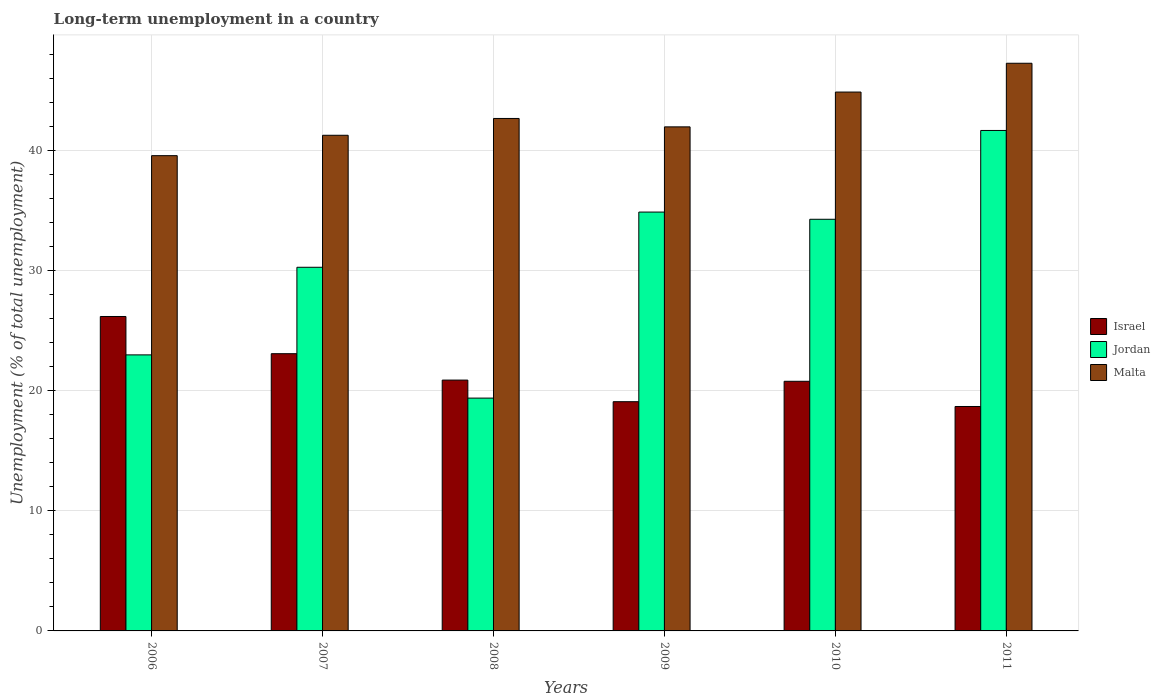How many different coloured bars are there?
Make the answer very short. 3. How many groups of bars are there?
Offer a very short reply. 6. Are the number of bars on each tick of the X-axis equal?
Ensure brevity in your answer.  Yes. How many bars are there on the 3rd tick from the right?
Offer a terse response. 3. What is the percentage of long-term unemployed population in Israel in 2008?
Offer a very short reply. 20.9. Across all years, what is the maximum percentage of long-term unemployed population in Malta?
Keep it short and to the point. 47.3. Across all years, what is the minimum percentage of long-term unemployed population in Jordan?
Provide a succinct answer. 19.4. In which year was the percentage of long-term unemployed population in Malta minimum?
Make the answer very short. 2006. What is the total percentage of long-term unemployed population in Israel in the graph?
Offer a very short reply. 128.8. What is the difference between the percentage of long-term unemployed population in Israel in 2008 and that in 2009?
Offer a terse response. 1.8. What is the difference between the percentage of long-term unemployed population in Israel in 2008 and the percentage of long-term unemployed population in Malta in 2007?
Keep it short and to the point. -20.4. What is the average percentage of long-term unemployed population in Jordan per year?
Your response must be concise. 30.6. In the year 2010, what is the difference between the percentage of long-term unemployed population in Malta and percentage of long-term unemployed population in Jordan?
Provide a succinct answer. 10.6. In how many years, is the percentage of long-term unemployed population in Jordan greater than 12 %?
Provide a short and direct response. 6. What is the ratio of the percentage of long-term unemployed population in Malta in 2007 to that in 2009?
Offer a very short reply. 0.98. Is the difference between the percentage of long-term unemployed population in Malta in 2006 and 2011 greater than the difference between the percentage of long-term unemployed population in Jordan in 2006 and 2011?
Your answer should be very brief. Yes. What is the difference between the highest and the second highest percentage of long-term unemployed population in Israel?
Give a very brief answer. 3.1. What is the difference between the highest and the lowest percentage of long-term unemployed population in Jordan?
Make the answer very short. 22.3. In how many years, is the percentage of long-term unemployed population in Jordan greater than the average percentage of long-term unemployed population in Jordan taken over all years?
Give a very brief answer. 3. Is the sum of the percentage of long-term unemployed population in Israel in 2007 and 2010 greater than the maximum percentage of long-term unemployed population in Jordan across all years?
Your answer should be compact. Yes. What does the 2nd bar from the right in 2006 represents?
Keep it short and to the point. Jordan. Is it the case that in every year, the sum of the percentage of long-term unemployed population in Malta and percentage of long-term unemployed population in Israel is greater than the percentage of long-term unemployed population in Jordan?
Your response must be concise. Yes. Are all the bars in the graph horizontal?
Offer a terse response. No. How many years are there in the graph?
Keep it short and to the point. 6. What is the difference between two consecutive major ticks on the Y-axis?
Offer a very short reply. 10. Are the values on the major ticks of Y-axis written in scientific E-notation?
Your answer should be compact. No. Does the graph contain any zero values?
Ensure brevity in your answer.  No. How are the legend labels stacked?
Offer a very short reply. Vertical. What is the title of the graph?
Your answer should be very brief. Long-term unemployment in a country. Does "Europe(developing only)" appear as one of the legend labels in the graph?
Keep it short and to the point. No. What is the label or title of the X-axis?
Ensure brevity in your answer.  Years. What is the label or title of the Y-axis?
Provide a succinct answer. Unemployment (% of total unemployment). What is the Unemployment (% of total unemployment) of Israel in 2006?
Keep it short and to the point. 26.2. What is the Unemployment (% of total unemployment) in Jordan in 2006?
Your answer should be very brief. 23. What is the Unemployment (% of total unemployment) in Malta in 2006?
Your response must be concise. 39.6. What is the Unemployment (% of total unemployment) of Israel in 2007?
Provide a succinct answer. 23.1. What is the Unemployment (% of total unemployment) of Jordan in 2007?
Offer a very short reply. 30.3. What is the Unemployment (% of total unemployment) in Malta in 2007?
Give a very brief answer. 41.3. What is the Unemployment (% of total unemployment) of Israel in 2008?
Your response must be concise. 20.9. What is the Unemployment (% of total unemployment) in Jordan in 2008?
Ensure brevity in your answer.  19.4. What is the Unemployment (% of total unemployment) of Malta in 2008?
Ensure brevity in your answer.  42.7. What is the Unemployment (% of total unemployment) of Israel in 2009?
Ensure brevity in your answer.  19.1. What is the Unemployment (% of total unemployment) in Jordan in 2009?
Provide a short and direct response. 34.9. What is the Unemployment (% of total unemployment) of Israel in 2010?
Offer a very short reply. 20.8. What is the Unemployment (% of total unemployment) of Jordan in 2010?
Offer a very short reply. 34.3. What is the Unemployment (% of total unemployment) in Malta in 2010?
Your answer should be compact. 44.9. What is the Unemployment (% of total unemployment) of Israel in 2011?
Provide a succinct answer. 18.7. What is the Unemployment (% of total unemployment) in Jordan in 2011?
Offer a very short reply. 41.7. What is the Unemployment (% of total unemployment) of Malta in 2011?
Offer a terse response. 47.3. Across all years, what is the maximum Unemployment (% of total unemployment) of Israel?
Your response must be concise. 26.2. Across all years, what is the maximum Unemployment (% of total unemployment) of Jordan?
Provide a succinct answer. 41.7. Across all years, what is the maximum Unemployment (% of total unemployment) of Malta?
Offer a terse response. 47.3. Across all years, what is the minimum Unemployment (% of total unemployment) in Israel?
Offer a terse response. 18.7. Across all years, what is the minimum Unemployment (% of total unemployment) of Jordan?
Offer a very short reply. 19.4. Across all years, what is the minimum Unemployment (% of total unemployment) of Malta?
Your answer should be compact. 39.6. What is the total Unemployment (% of total unemployment) in Israel in the graph?
Ensure brevity in your answer.  128.8. What is the total Unemployment (% of total unemployment) in Jordan in the graph?
Make the answer very short. 183.6. What is the total Unemployment (% of total unemployment) in Malta in the graph?
Give a very brief answer. 257.8. What is the difference between the Unemployment (% of total unemployment) in Israel in 2006 and that in 2007?
Make the answer very short. 3.1. What is the difference between the Unemployment (% of total unemployment) in Israel in 2006 and that in 2008?
Offer a terse response. 5.3. What is the difference between the Unemployment (% of total unemployment) in Malta in 2006 and that in 2008?
Your answer should be compact. -3.1. What is the difference between the Unemployment (% of total unemployment) in Israel in 2006 and that in 2009?
Give a very brief answer. 7.1. What is the difference between the Unemployment (% of total unemployment) in Jordan in 2006 and that in 2009?
Give a very brief answer. -11.9. What is the difference between the Unemployment (% of total unemployment) in Israel in 2006 and that in 2010?
Give a very brief answer. 5.4. What is the difference between the Unemployment (% of total unemployment) in Malta in 2006 and that in 2010?
Ensure brevity in your answer.  -5.3. What is the difference between the Unemployment (% of total unemployment) in Israel in 2006 and that in 2011?
Your answer should be very brief. 7.5. What is the difference between the Unemployment (% of total unemployment) of Jordan in 2006 and that in 2011?
Offer a terse response. -18.7. What is the difference between the Unemployment (% of total unemployment) in Jordan in 2007 and that in 2008?
Provide a short and direct response. 10.9. What is the difference between the Unemployment (% of total unemployment) in Malta in 2007 and that in 2008?
Offer a terse response. -1.4. What is the difference between the Unemployment (% of total unemployment) of Israel in 2007 and that in 2009?
Make the answer very short. 4. What is the difference between the Unemployment (% of total unemployment) in Israel in 2007 and that in 2010?
Make the answer very short. 2.3. What is the difference between the Unemployment (% of total unemployment) in Jordan in 2007 and that in 2010?
Ensure brevity in your answer.  -4. What is the difference between the Unemployment (% of total unemployment) in Israel in 2007 and that in 2011?
Provide a short and direct response. 4.4. What is the difference between the Unemployment (% of total unemployment) in Jordan in 2007 and that in 2011?
Make the answer very short. -11.4. What is the difference between the Unemployment (% of total unemployment) of Jordan in 2008 and that in 2009?
Make the answer very short. -15.5. What is the difference between the Unemployment (% of total unemployment) of Malta in 2008 and that in 2009?
Make the answer very short. 0.7. What is the difference between the Unemployment (% of total unemployment) of Israel in 2008 and that in 2010?
Ensure brevity in your answer.  0.1. What is the difference between the Unemployment (% of total unemployment) in Jordan in 2008 and that in 2010?
Give a very brief answer. -14.9. What is the difference between the Unemployment (% of total unemployment) in Israel in 2008 and that in 2011?
Make the answer very short. 2.2. What is the difference between the Unemployment (% of total unemployment) in Jordan in 2008 and that in 2011?
Offer a very short reply. -22.3. What is the difference between the Unemployment (% of total unemployment) of Malta in 2008 and that in 2011?
Offer a very short reply. -4.6. What is the difference between the Unemployment (% of total unemployment) of Jordan in 2009 and that in 2010?
Make the answer very short. 0.6. What is the difference between the Unemployment (% of total unemployment) in Israel in 2010 and that in 2011?
Keep it short and to the point. 2.1. What is the difference between the Unemployment (% of total unemployment) in Malta in 2010 and that in 2011?
Give a very brief answer. -2.4. What is the difference between the Unemployment (% of total unemployment) in Israel in 2006 and the Unemployment (% of total unemployment) in Malta in 2007?
Offer a terse response. -15.1. What is the difference between the Unemployment (% of total unemployment) of Jordan in 2006 and the Unemployment (% of total unemployment) of Malta in 2007?
Your answer should be compact. -18.3. What is the difference between the Unemployment (% of total unemployment) of Israel in 2006 and the Unemployment (% of total unemployment) of Malta in 2008?
Your answer should be very brief. -16.5. What is the difference between the Unemployment (% of total unemployment) of Jordan in 2006 and the Unemployment (% of total unemployment) of Malta in 2008?
Your answer should be very brief. -19.7. What is the difference between the Unemployment (% of total unemployment) in Israel in 2006 and the Unemployment (% of total unemployment) in Malta in 2009?
Make the answer very short. -15.8. What is the difference between the Unemployment (% of total unemployment) in Israel in 2006 and the Unemployment (% of total unemployment) in Malta in 2010?
Give a very brief answer. -18.7. What is the difference between the Unemployment (% of total unemployment) of Jordan in 2006 and the Unemployment (% of total unemployment) of Malta in 2010?
Offer a very short reply. -21.9. What is the difference between the Unemployment (% of total unemployment) of Israel in 2006 and the Unemployment (% of total unemployment) of Jordan in 2011?
Offer a terse response. -15.5. What is the difference between the Unemployment (% of total unemployment) in Israel in 2006 and the Unemployment (% of total unemployment) in Malta in 2011?
Keep it short and to the point. -21.1. What is the difference between the Unemployment (% of total unemployment) in Jordan in 2006 and the Unemployment (% of total unemployment) in Malta in 2011?
Ensure brevity in your answer.  -24.3. What is the difference between the Unemployment (% of total unemployment) of Israel in 2007 and the Unemployment (% of total unemployment) of Malta in 2008?
Provide a succinct answer. -19.6. What is the difference between the Unemployment (% of total unemployment) of Jordan in 2007 and the Unemployment (% of total unemployment) of Malta in 2008?
Your answer should be compact. -12.4. What is the difference between the Unemployment (% of total unemployment) in Israel in 2007 and the Unemployment (% of total unemployment) in Malta in 2009?
Provide a succinct answer. -18.9. What is the difference between the Unemployment (% of total unemployment) of Jordan in 2007 and the Unemployment (% of total unemployment) of Malta in 2009?
Offer a terse response. -11.7. What is the difference between the Unemployment (% of total unemployment) in Israel in 2007 and the Unemployment (% of total unemployment) in Jordan in 2010?
Provide a succinct answer. -11.2. What is the difference between the Unemployment (% of total unemployment) in Israel in 2007 and the Unemployment (% of total unemployment) in Malta in 2010?
Your answer should be very brief. -21.8. What is the difference between the Unemployment (% of total unemployment) of Jordan in 2007 and the Unemployment (% of total unemployment) of Malta in 2010?
Your response must be concise. -14.6. What is the difference between the Unemployment (% of total unemployment) of Israel in 2007 and the Unemployment (% of total unemployment) of Jordan in 2011?
Keep it short and to the point. -18.6. What is the difference between the Unemployment (% of total unemployment) in Israel in 2007 and the Unemployment (% of total unemployment) in Malta in 2011?
Ensure brevity in your answer.  -24.2. What is the difference between the Unemployment (% of total unemployment) of Israel in 2008 and the Unemployment (% of total unemployment) of Malta in 2009?
Keep it short and to the point. -21.1. What is the difference between the Unemployment (% of total unemployment) in Jordan in 2008 and the Unemployment (% of total unemployment) in Malta in 2009?
Provide a short and direct response. -22.6. What is the difference between the Unemployment (% of total unemployment) of Israel in 2008 and the Unemployment (% of total unemployment) of Jordan in 2010?
Ensure brevity in your answer.  -13.4. What is the difference between the Unemployment (% of total unemployment) of Jordan in 2008 and the Unemployment (% of total unemployment) of Malta in 2010?
Provide a succinct answer. -25.5. What is the difference between the Unemployment (% of total unemployment) of Israel in 2008 and the Unemployment (% of total unemployment) of Jordan in 2011?
Ensure brevity in your answer.  -20.8. What is the difference between the Unemployment (% of total unemployment) in Israel in 2008 and the Unemployment (% of total unemployment) in Malta in 2011?
Provide a short and direct response. -26.4. What is the difference between the Unemployment (% of total unemployment) in Jordan in 2008 and the Unemployment (% of total unemployment) in Malta in 2011?
Offer a very short reply. -27.9. What is the difference between the Unemployment (% of total unemployment) of Israel in 2009 and the Unemployment (% of total unemployment) of Jordan in 2010?
Give a very brief answer. -15.2. What is the difference between the Unemployment (% of total unemployment) of Israel in 2009 and the Unemployment (% of total unemployment) of Malta in 2010?
Offer a very short reply. -25.8. What is the difference between the Unemployment (% of total unemployment) in Israel in 2009 and the Unemployment (% of total unemployment) in Jordan in 2011?
Keep it short and to the point. -22.6. What is the difference between the Unemployment (% of total unemployment) in Israel in 2009 and the Unemployment (% of total unemployment) in Malta in 2011?
Offer a terse response. -28.2. What is the difference between the Unemployment (% of total unemployment) in Jordan in 2009 and the Unemployment (% of total unemployment) in Malta in 2011?
Provide a short and direct response. -12.4. What is the difference between the Unemployment (% of total unemployment) of Israel in 2010 and the Unemployment (% of total unemployment) of Jordan in 2011?
Provide a succinct answer. -20.9. What is the difference between the Unemployment (% of total unemployment) of Israel in 2010 and the Unemployment (% of total unemployment) of Malta in 2011?
Offer a very short reply. -26.5. What is the average Unemployment (% of total unemployment) in Israel per year?
Ensure brevity in your answer.  21.47. What is the average Unemployment (% of total unemployment) in Jordan per year?
Your answer should be very brief. 30.6. What is the average Unemployment (% of total unemployment) in Malta per year?
Your answer should be compact. 42.97. In the year 2006, what is the difference between the Unemployment (% of total unemployment) of Israel and Unemployment (% of total unemployment) of Malta?
Ensure brevity in your answer.  -13.4. In the year 2006, what is the difference between the Unemployment (% of total unemployment) of Jordan and Unemployment (% of total unemployment) of Malta?
Give a very brief answer. -16.6. In the year 2007, what is the difference between the Unemployment (% of total unemployment) of Israel and Unemployment (% of total unemployment) of Malta?
Give a very brief answer. -18.2. In the year 2008, what is the difference between the Unemployment (% of total unemployment) in Israel and Unemployment (% of total unemployment) in Jordan?
Your answer should be compact. 1.5. In the year 2008, what is the difference between the Unemployment (% of total unemployment) of Israel and Unemployment (% of total unemployment) of Malta?
Provide a short and direct response. -21.8. In the year 2008, what is the difference between the Unemployment (% of total unemployment) in Jordan and Unemployment (% of total unemployment) in Malta?
Your answer should be compact. -23.3. In the year 2009, what is the difference between the Unemployment (% of total unemployment) of Israel and Unemployment (% of total unemployment) of Jordan?
Ensure brevity in your answer.  -15.8. In the year 2009, what is the difference between the Unemployment (% of total unemployment) in Israel and Unemployment (% of total unemployment) in Malta?
Your response must be concise. -22.9. In the year 2010, what is the difference between the Unemployment (% of total unemployment) in Israel and Unemployment (% of total unemployment) in Malta?
Provide a short and direct response. -24.1. In the year 2010, what is the difference between the Unemployment (% of total unemployment) in Jordan and Unemployment (% of total unemployment) in Malta?
Offer a terse response. -10.6. In the year 2011, what is the difference between the Unemployment (% of total unemployment) in Israel and Unemployment (% of total unemployment) in Malta?
Your answer should be compact. -28.6. In the year 2011, what is the difference between the Unemployment (% of total unemployment) of Jordan and Unemployment (% of total unemployment) of Malta?
Your answer should be very brief. -5.6. What is the ratio of the Unemployment (% of total unemployment) in Israel in 2006 to that in 2007?
Your response must be concise. 1.13. What is the ratio of the Unemployment (% of total unemployment) of Jordan in 2006 to that in 2007?
Provide a succinct answer. 0.76. What is the ratio of the Unemployment (% of total unemployment) of Malta in 2006 to that in 2007?
Your answer should be compact. 0.96. What is the ratio of the Unemployment (% of total unemployment) of Israel in 2006 to that in 2008?
Provide a succinct answer. 1.25. What is the ratio of the Unemployment (% of total unemployment) in Jordan in 2006 to that in 2008?
Give a very brief answer. 1.19. What is the ratio of the Unemployment (% of total unemployment) in Malta in 2006 to that in 2008?
Keep it short and to the point. 0.93. What is the ratio of the Unemployment (% of total unemployment) of Israel in 2006 to that in 2009?
Your answer should be very brief. 1.37. What is the ratio of the Unemployment (% of total unemployment) of Jordan in 2006 to that in 2009?
Provide a short and direct response. 0.66. What is the ratio of the Unemployment (% of total unemployment) of Malta in 2006 to that in 2009?
Offer a terse response. 0.94. What is the ratio of the Unemployment (% of total unemployment) of Israel in 2006 to that in 2010?
Your response must be concise. 1.26. What is the ratio of the Unemployment (% of total unemployment) of Jordan in 2006 to that in 2010?
Offer a terse response. 0.67. What is the ratio of the Unemployment (% of total unemployment) in Malta in 2006 to that in 2010?
Ensure brevity in your answer.  0.88. What is the ratio of the Unemployment (% of total unemployment) in Israel in 2006 to that in 2011?
Ensure brevity in your answer.  1.4. What is the ratio of the Unemployment (% of total unemployment) of Jordan in 2006 to that in 2011?
Your response must be concise. 0.55. What is the ratio of the Unemployment (% of total unemployment) in Malta in 2006 to that in 2011?
Your answer should be very brief. 0.84. What is the ratio of the Unemployment (% of total unemployment) of Israel in 2007 to that in 2008?
Offer a terse response. 1.11. What is the ratio of the Unemployment (% of total unemployment) of Jordan in 2007 to that in 2008?
Your answer should be compact. 1.56. What is the ratio of the Unemployment (% of total unemployment) in Malta in 2007 to that in 2008?
Keep it short and to the point. 0.97. What is the ratio of the Unemployment (% of total unemployment) in Israel in 2007 to that in 2009?
Offer a very short reply. 1.21. What is the ratio of the Unemployment (% of total unemployment) of Jordan in 2007 to that in 2009?
Your answer should be compact. 0.87. What is the ratio of the Unemployment (% of total unemployment) in Malta in 2007 to that in 2009?
Your response must be concise. 0.98. What is the ratio of the Unemployment (% of total unemployment) in Israel in 2007 to that in 2010?
Give a very brief answer. 1.11. What is the ratio of the Unemployment (% of total unemployment) of Jordan in 2007 to that in 2010?
Your answer should be very brief. 0.88. What is the ratio of the Unemployment (% of total unemployment) in Malta in 2007 to that in 2010?
Your answer should be compact. 0.92. What is the ratio of the Unemployment (% of total unemployment) in Israel in 2007 to that in 2011?
Provide a succinct answer. 1.24. What is the ratio of the Unemployment (% of total unemployment) in Jordan in 2007 to that in 2011?
Ensure brevity in your answer.  0.73. What is the ratio of the Unemployment (% of total unemployment) of Malta in 2007 to that in 2011?
Keep it short and to the point. 0.87. What is the ratio of the Unemployment (% of total unemployment) of Israel in 2008 to that in 2009?
Your answer should be very brief. 1.09. What is the ratio of the Unemployment (% of total unemployment) in Jordan in 2008 to that in 2009?
Your answer should be very brief. 0.56. What is the ratio of the Unemployment (% of total unemployment) in Malta in 2008 to that in 2009?
Provide a succinct answer. 1.02. What is the ratio of the Unemployment (% of total unemployment) in Israel in 2008 to that in 2010?
Ensure brevity in your answer.  1. What is the ratio of the Unemployment (% of total unemployment) in Jordan in 2008 to that in 2010?
Provide a succinct answer. 0.57. What is the ratio of the Unemployment (% of total unemployment) of Malta in 2008 to that in 2010?
Offer a terse response. 0.95. What is the ratio of the Unemployment (% of total unemployment) of Israel in 2008 to that in 2011?
Provide a short and direct response. 1.12. What is the ratio of the Unemployment (% of total unemployment) in Jordan in 2008 to that in 2011?
Your answer should be compact. 0.47. What is the ratio of the Unemployment (% of total unemployment) of Malta in 2008 to that in 2011?
Ensure brevity in your answer.  0.9. What is the ratio of the Unemployment (% of total unemployment) in Israel in 2009 to that in 2010?
Give a very brief answer. 0.92. What is the ratio of the Unemployment (% of total unemployment) of Jordan in 2009 to that in 2010?
Offer a very short reply. 1.02. What is the ratio of the Unemployment (% of total unemployment) in Malta in 2009 to that in 2010?
Your answer should be very brief. 0.94. What is the ratio of the Unemployment (% of total unemployment) in Israel in 2009 to that in 2011?
Ensure brevity in your answer.  1.02. What is the ratio of the Unemployment (% of total unemployment) in Jordan in 2009 to that in 2011?
Ensure brevity in your answer.  0.84. What is the ratio of the Unemployment (% of total unemployment) in Malta in 2009 to that in 2011?
Your answer should be very brief. 0.89. What is the ratio of the Unemployment (% of total unemployment) of Israel in 2010 to that in 2011?
Keep it short and to the point. 1.11. What is the ratio of the Unemployment (% of total unemployment) of Jordan in 2010 to that in 2011?
Offer a terse response. 0.82. What is the ratio of the Unemployment (% of total unemployment) in Malta in 2010 to that in 2011?
Make the answer very short. 0.95. What is the difference between the highest and the second highest Unemployment (% of total unemployment) of Israel?
Your response must be concise. 3.1. What is the difference between the highest and the second highest Unemployment (% of total unemployment) in Jordan?
Make the answer very short. 6.8. What is the difference between the highest and the lowest Unemployment (% of total unemployment) in Israel?
Your response must be concise. 7.5. What is the difference between the highest and the lowest Unemployment (% of total unemployment) of Jordan?
Your answer should be compact. 22.3. What is the difference between the highest and the lowest Unemployment (% of total unemployment) in Malta?
Ensure brevity in your answer.  7.7. 